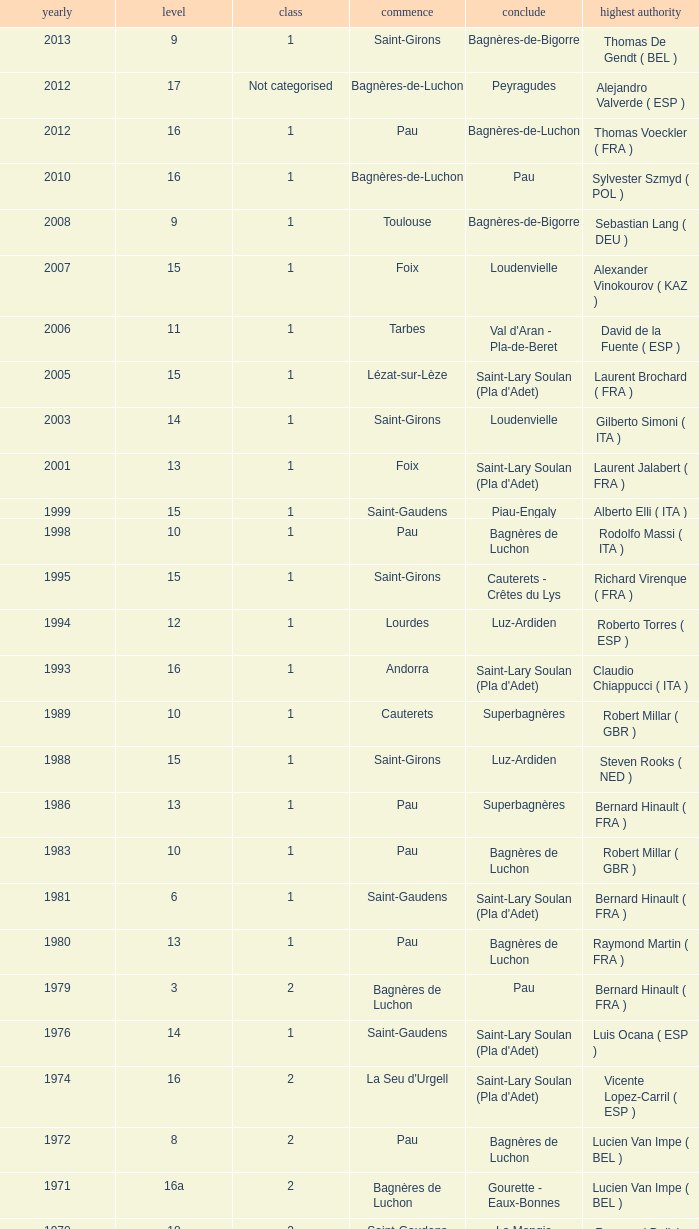What stage has a start of saint-girons in 1988? 15.0. 